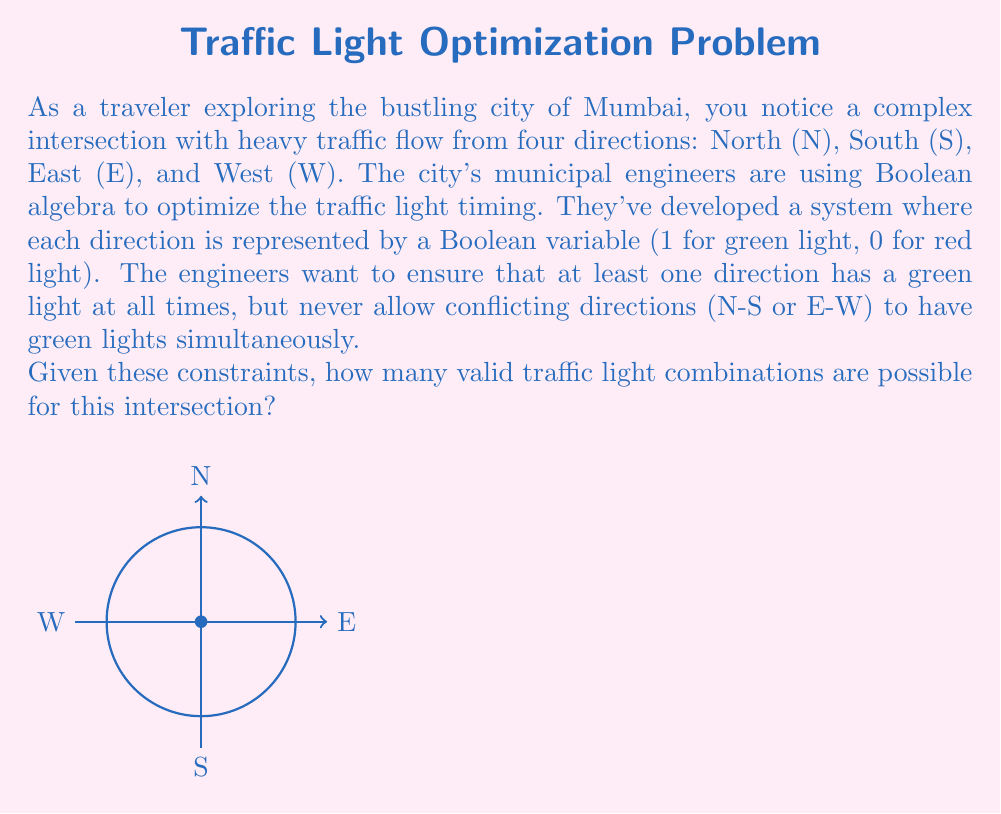Provide a solution to this math problem. Let's approach this step-by-step using Boolean algebra:

1) We have four Boolean variables: N, S, E, and W.

2) The constraint that conflicting directions can't be green simultaneously can be expressed as:
   $$(N \cdot S = 0) \text{ and } (E \cdot W = 0)$$

3) The requirement that at least one direction must be green can be expressed as:
   $$(N + S + E + W = 1)$$

4) Now, let's list all possible combinations and eliminate invalid ones:

   $$(N,S,E,W) = (0,0,0,0)$$ - Invalid (no green light)
   $$(N,S,E,W) = (1,0,0,0)$$ - Valid
   $$(N,S,E,W) = (0,1,0,0)$$ - Valid
   $$(N,S,E,W) = (0,0,1,0)$$ - Valid
   $$(N,S,E,W) = (0,0,0,1)$$ - Valid
   $$(N,S,E,W) = (1,1,0,0)$$ - Invalid (N and S both green)
   $$(N,S,E,W) = (1,0,1,0)$$ - Valid
   $$(N,S,E,W) = (1,0,0,1)$$ - Valid
   $$(N,S,E,W) = (0,1,1,0)$$ - Valid
   $$(N,S,E,W) = (0,1,0,1)$$ - Valid
   $$(N,S,E,W) = (0,0,1,1)$$ - Invalid (E and W both green)

5) Counting the valid combinations, we find that there are 8 possible valid traffic light combinations.
Answer: 8 